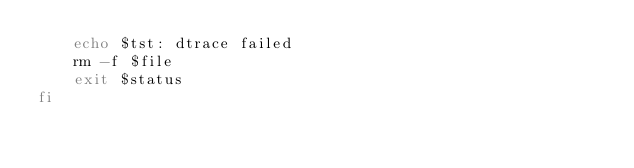<code> <loc_0><loc_0><loc_500><loc_500><_Bash_>	echo $tst: dtrace failed
	rm -f $file
	exit $status
fi
</code> 